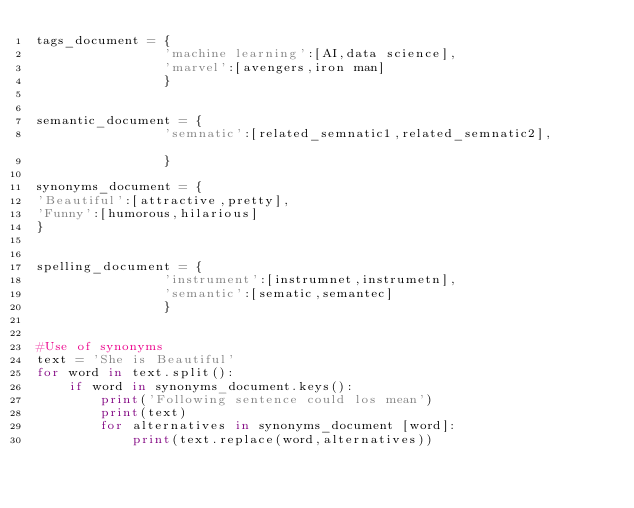<code> <loc_0><loc_0><loc_500><loc_500><_Python_>tags_document = {
				'machine learning':[AI,data science],
				'marvel':[avengers,iron man]
				}				
				
				
semantic_document = {
				'semnatic':[related_semnatic1,related_semnatic2],				
				}

synonyms_document = {
'Beautiful':[attractive,pretty],
'Funny':[humorous,hilarious]
}
				
				
spelling_document = {
				'instrument':[instrumnet,instrumetn],
				'semantic':[sematic,semantec]
				}
				
				
#Use of synonyms				
text = 'She is Beautiful'
for word in text.split():
	if word in synonyms_document.keys():
		print('Following sentence could los mean')
		print(text)		
		for alternatives in synonyms_document [word]:
			print(text.replace(word,alternatives))</code> 